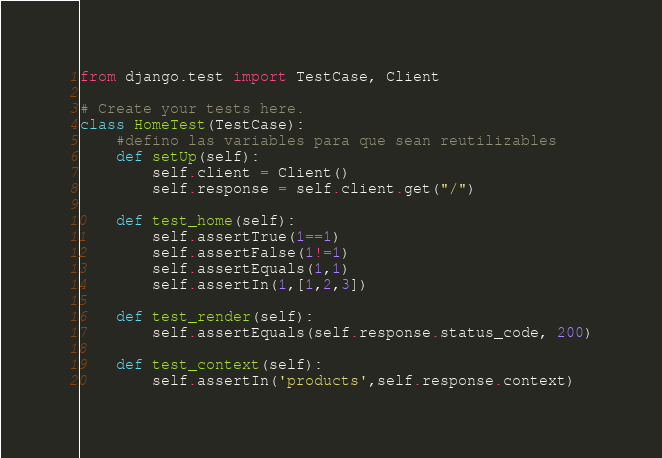Convert code to text. <code><loc_0><loc_0><loc_500><loc_500><_Python_>from django.test import TestCase, Client

# Create your tests here.
class HomeTest(TestCase):
	#defino las variables para que sean reutilizables
	def setUp(self):
		self.client = Client()
		self.response = self.client.get("/")

	def test_home(self):
		self.assertTrue(1==1)
		self.assertFalse(1!=1)
		self.assertEquals(1,1)
		self.assertIn(1,[1,2,3])

	def test_render(self):
		self.assertEquals(self.response.status_code, 200)

	def test_context(self):
		self.assertIn('products',self.response.context)</code> 